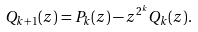Convert formula to latex. <formula><loc_0><loc_0><loc_500><loc_500>Q _ { k + 1 } ( z ) = P _ { k } ( z ) - z ^ { 2 ^ { k } } Q _ { k } ( z ) .</formula> 